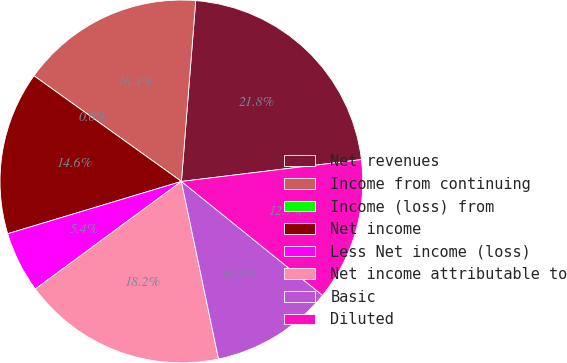Convert chart to OTSL. <chart><loc_0><loc_0><loc_500><loc_500><pie_chart><fcel>Net revenues<fcel>Income from continuing<fcel>Income (loss) from<fcel>Net income<fcel>Less Net income (loss)<fcel>Net income attributable to<fcel>Basic<fcel>Diluted<nl><fcel>21.82%<fcel>16.36%<fcel>0.0%<fcel>14.55%<fcel>5.45%<fcel>18.18%<fcel>10.91%<fcel>12.73%<nl></chart> 